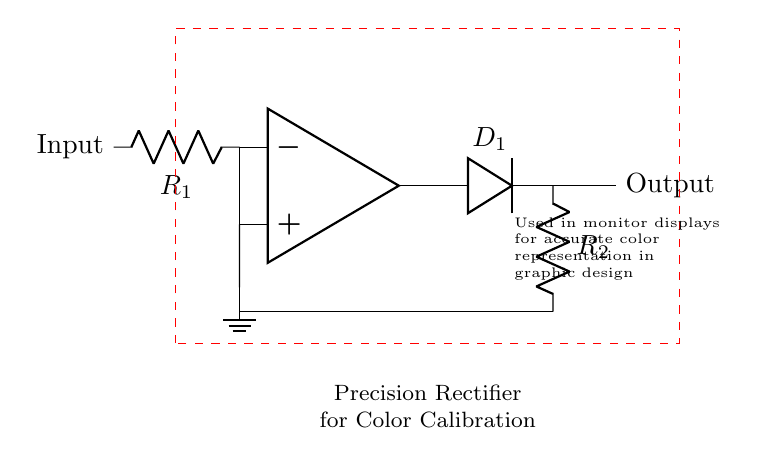What are the main components in this circuit? The circuit consists of an operational amplifier, a resistor (R1), a diode (D1), and another resistor (R2). These components work together to create a precision rectifier setup.
Answer: operational amplifier, resistor, diode, resistor What does the dashed red rectangle indicate? The dashed red rectangle outlines the precision rectifier circuit's area, indicating it as a specific functional block in the design used for color calibration.
Answer: precision rectifier circuit What is the function of the diode (D1) in the circuit? The diode allows current to flow in one direction only, which is essential for rectifying the input signal, converting it from AC to DC, which is necessary for accurate color calibration.
Answer: rectification How does the input connect to the operational amplifier? The input connects to the inverting terminal (negative input) of the operational amplifier through resistor R1, which influences the op-amp's behavior in the circuit.
Answer: through resistor R1 What is the output of the circuit labeled as? The output is labeled simply as "Output," indicating the signal's processed result that is ready for further applications like color calibration in monitors.
Answer: Output What is the purpose of this precision rectifier circuit specifically? This precision rectifier circuit is designed for accurate color calibration in monitor displays, ensuring that graphic artists can see true color representations and make informed decisions during design work.
Answer: accurate color calibration What is the value of R1 and R2? The schematic does not specify exact values for R1 and R2 since they are variables that depend on circuit requirements for precision.
Answer: unspecified 